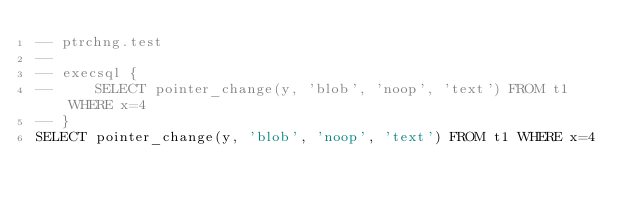<code> <loc_0><loc_0><loc_500><loc_500><_SQL_>-- ptrchng.test
-- 
-- execsql {
--     SELECT pointer_change(y, 'blob', 'noop', 'text') FROM t1 WHERE x=4
-- }
SELECT pointer_change(y, 'blob', 'noop', 'text') FROM t1 WHERE x=4</code> 